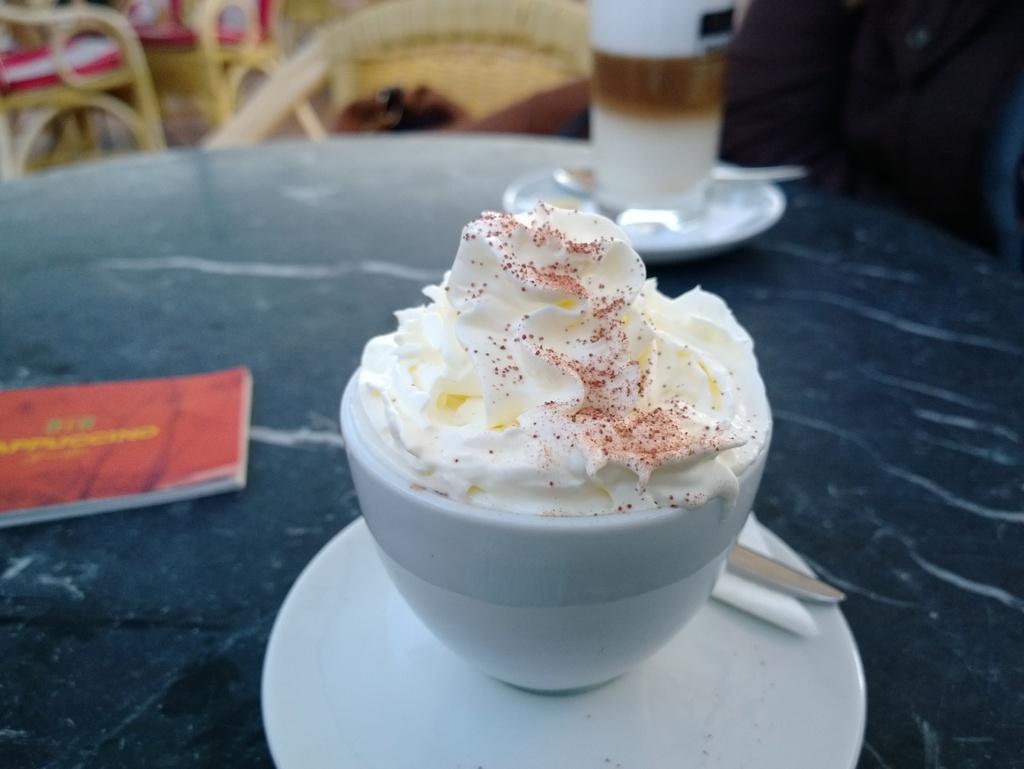Can you describe this image briefly? In the image there is a dessert served with a saucer and there are two other items kept beside the dessert on the table and the background is blur. 